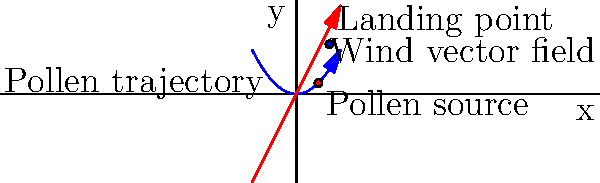Given a wind vector field represented by $\mathbf{F}(x,y) = (2x, y)$ and a pollen grain released from a plant at point $(1, 0.5)$, calculate the x-coordinate of the pollen's landing point if it travels for 0.5 units of time following the wind field. Assume the pollen's velocity is equal to the wind vector at each point. To solve this problem, we need to follow these steps:

1) The wind vector field is given by $\mathbf{F}(x,y) = (2x, y)$. This means that at any point $(x,y)$, the wind velocity is $(2x, y)$.

2) The pollen's initial position is $(1, 0.5)$. Let's call the pollen's position at time $t$ as $(x(t), y(t))$.

3) Since the pollen's velocity is equal to the wind vector at each point, we can write:

   $\frac{dx}{dt} = 2x$ and $\frac{dy}{dt} = y$

4) For the x-coordinate, we need to solve the differential equation:
   $\frac{dx}{dt} = 2x$

5) This is a separable equation. Solving it:
   $\int \frac{dx}{x} = \int 2dt$
   $\ln|x| = 2t + C$
   $x = Ce^{2t}$

6) Using the initial condition $x(0) = 1$, we find $C = 1$. So:
   $x(t) = e^{2t}$

7) We're asked to find the x-coordinate after 0.5 units of time. So:
   $x(0.5) = e^{2(0.5)} = e^1 \approx 2.718$

Therefore, after 0.5 units of time, the x-coordinate of the pollen grain will be approximately 2.718.
Answer: 2.718 